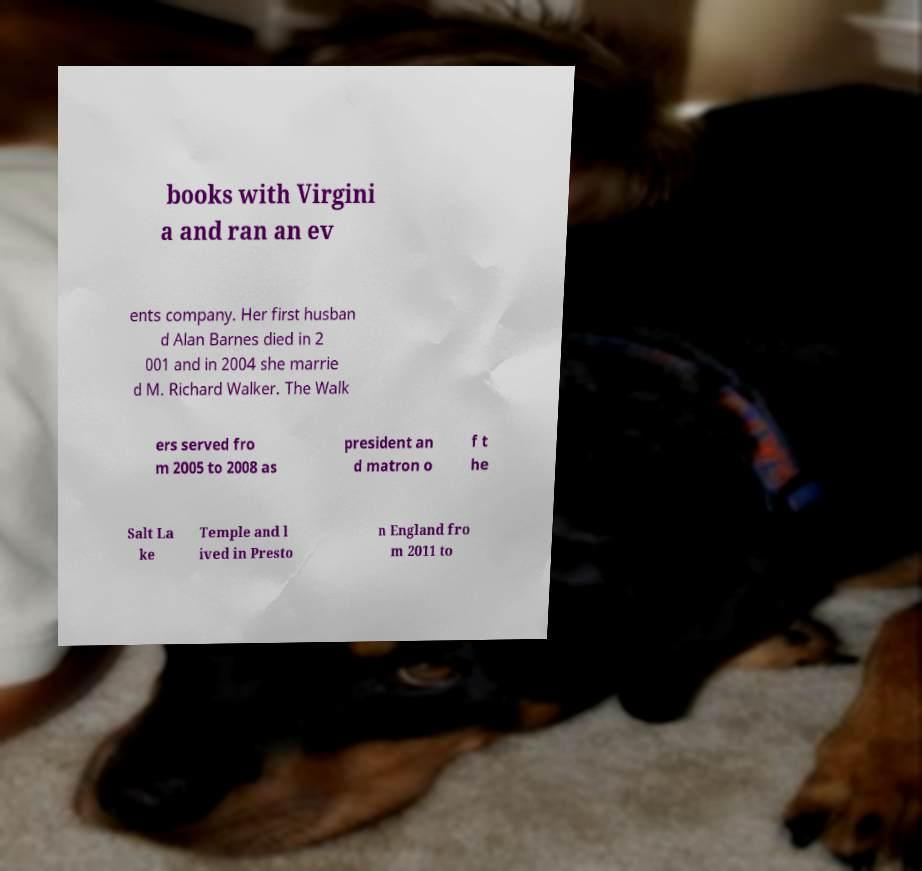What messages or text are displayed in this image? I need them in a readable, typed format. books with Virgini a and ran an ev ents company. Her first husban d Alan Barnes died in 2 001 and in 2004 she marrie d M. Richard Walker. The Walk ers served fro m 2005 to 2008 as president an d matron o f t he Salt La ke Temple and l ived in Presto n England fro m 2011 to 